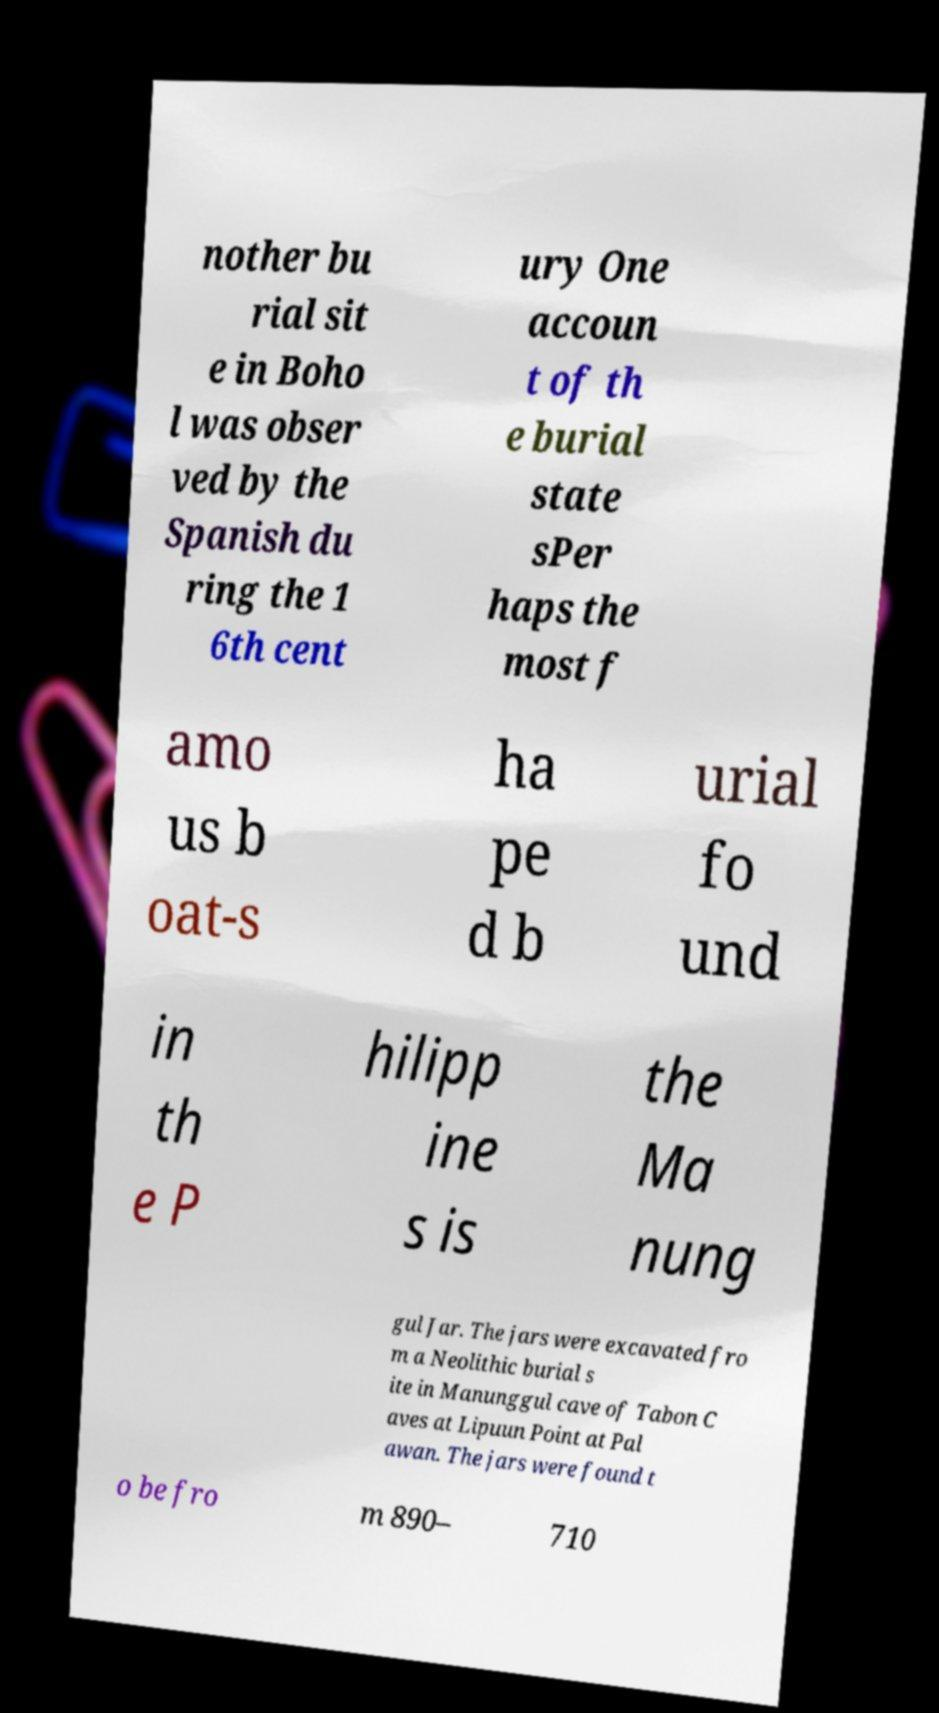Please read and relay the text visible in this image. What does it say? nother bu rial sit e in Boho l was obser ved by the Spanish du ring the 1 6th cent ury One accoun t of th e burial state sPer haps the most f amo us b oat-s ha pe d b urial fo und in th e P hilipp ine s is the Ma nung gul Jar. The jars were excavated fro m a Neolithic burial s ite in Manunggul cave of Tabon C aves at Lipuun Point at Pal awan. The jars were found t o be fro m 890– 710 